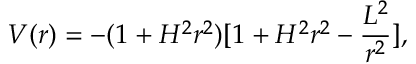Convert formula to latex. <formula><loc_0><loc_0><loc_500><loc_500>V ( r ) = - ( 1 + H ^ { 2 } r ^ { 2 } ) [ 1 + H ^ { 2 } r ^ { 2 } - \frac { L ^ { 2 } } { r ^ { 2 } } ] ,</formula> 